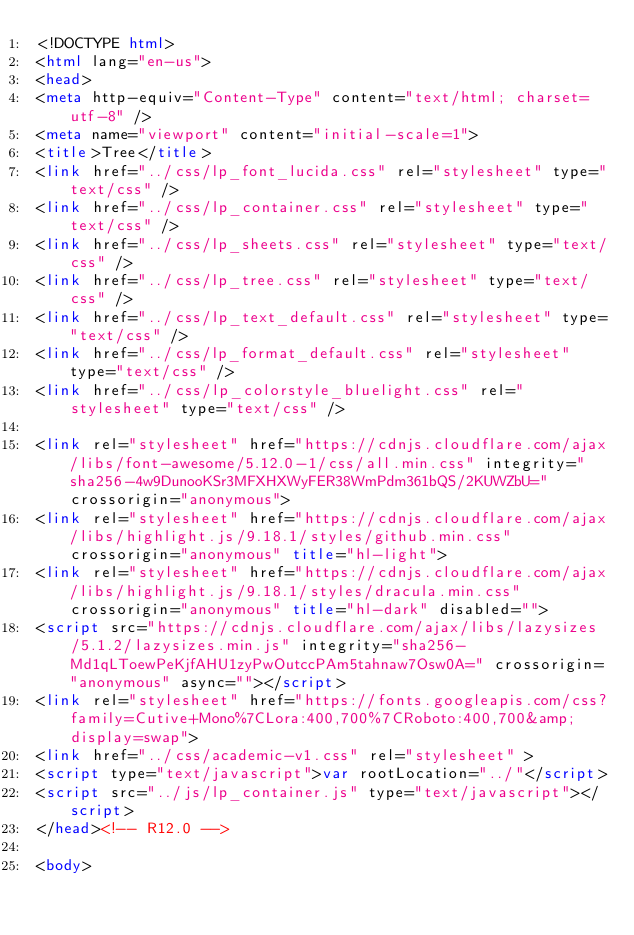<code> <loc_0><loc_0><loc_500><loc_500><_HTML_><!DOCTYPE html>
<html lang="en-us">
<head>
<meta http-equiv="Content-Type" content="text/html; charset=utf-8" />
<meta name="viewport" content="initial-scale=1">
<title>Tree</title>
<link href="../css/lp_font_lucida.css" rel="stylesheet" type="text/css" />
<link href="../css/lp_container.css" rel="stylesheet" type="text/css" />
<link href="../css/lp_sheets.css" rel="stylesheet" type="text/css" />
<link href="../css/lp_tree.css" rel="stylesheet" type="text/css" />
<link href="../css/lp_text_default.css" rel="stylesheet" type="text/css" />
<link href="../css/lp_format_default.css" rel="stylesheet" type="text/css" />
<link href="../css/lp_colorstyle_bluelight.css" rel="stylesheet" type="text/css" />

<link rel="stylesheet" href="https://cdnjs.cloudflare.com/ajax/libs/font-awesome/5.12.0-1/css/all.min.css" integrity="sha256-4w9DunooKSr3MFXHXWyFER38WmPdm361bQS/2KUWZbU=" crossorigin="anonymous">
<link rel="stylesheet" href="https://cdnjs.cloudflare.com/ajax/libs/highlight.js/9.18.1/styles/github.min.css" crossorigin="anonymous" title="hl-light">
<link rel="stylesheet" href="https://cdnjs.cloudflare.com/ajax/libs/highlight.js/9.18.1/styles/dracula.min.css" crossorigin="anonymous" title="hl-dark" disabled="">
<script src="https://cdnjs.cloudflare.com/ajax/libs/lazysizes/5.1.2/lazysizes.min.js" integrity="sha256-Md1qLToewPeKjfAHU1zyPwOutccPAm5tahnaw7Osw0A=" crossorigin="anonymous" async=""></script>
<link rel="stylesheet" href="https://fonts.googleapis.com/css?family=Cutive+Mono%7CLora:400,700%7CRoboto:400,700&amp;display=swap">
<link href="../css/academic-v1.css" rel="stylesheet" >
<script type="text/javascript">var rootLocation="../"</script>
<script src="../js/lp_container.js" type="text/javascript"></script>
</head><!-- R12.0 -->

<body></code> 